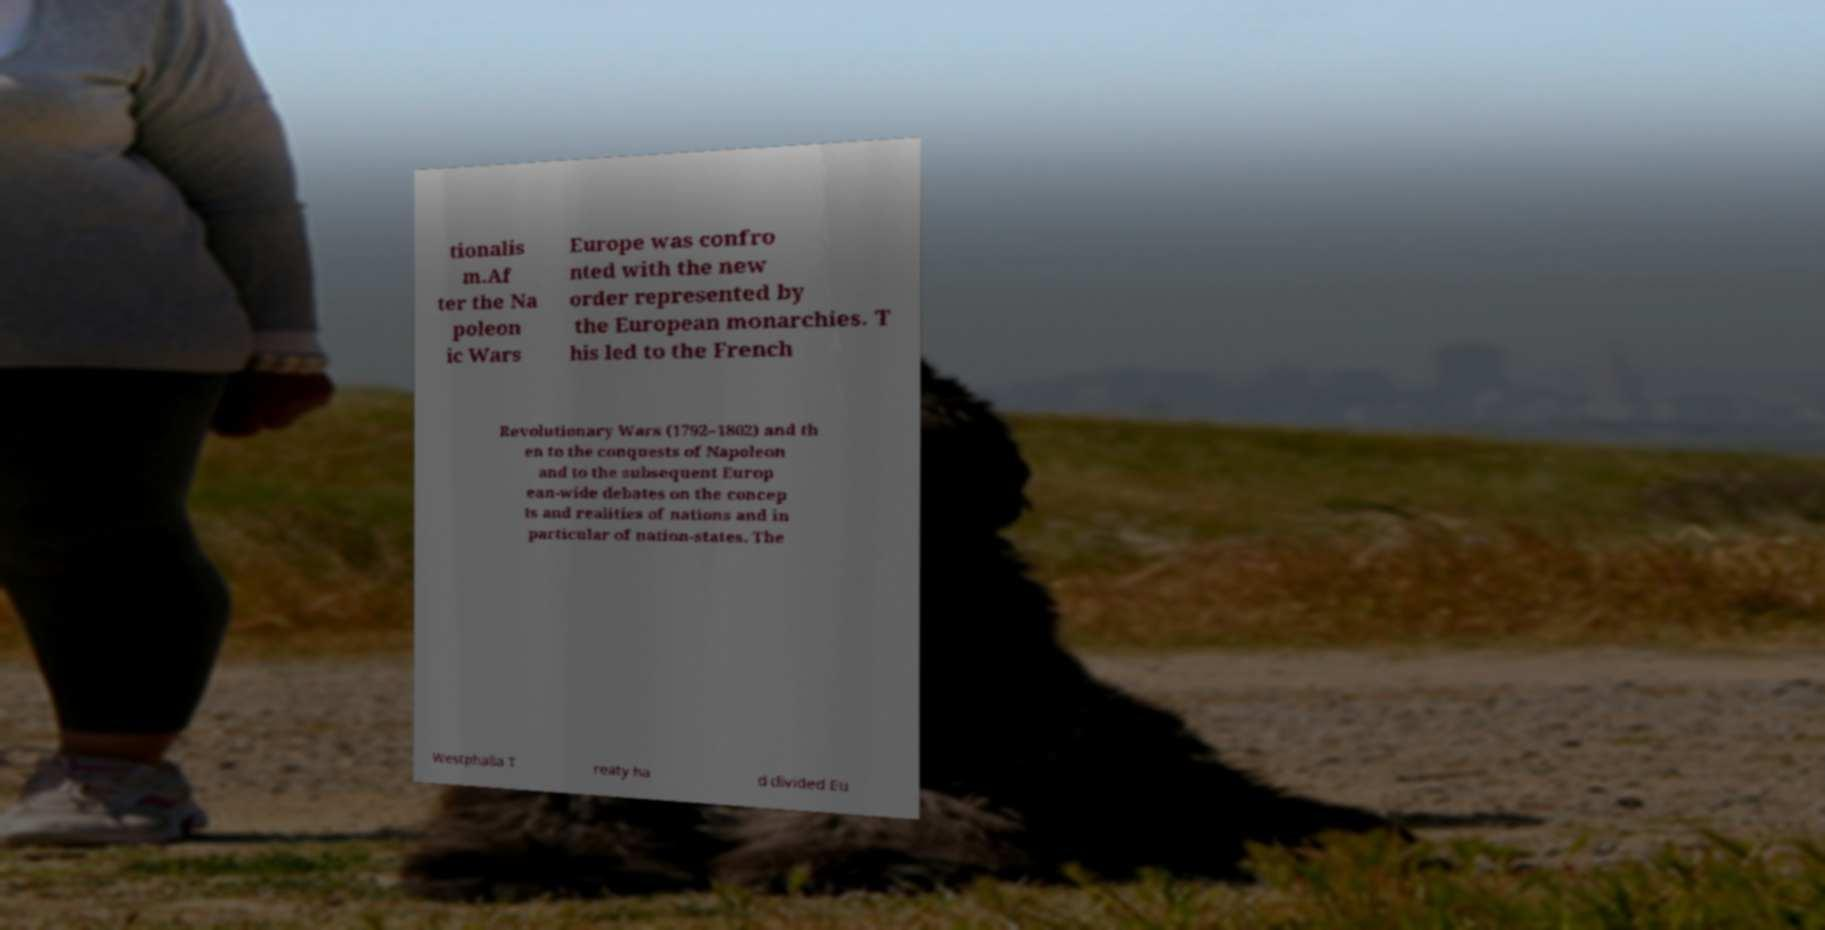Can you accurately transcribe the text from the provided image for me? tionalis m.Af ter the Na poleon ic Wars Europe was confro nted with the new order represented by the European monarchies. T his led to the French Revolutionary Wars (1792–1802) and th en to the conquests of Napoleon and to the subsequent Europ ean-wide debates on the concep ts and realities of nations and in particular of nation-states. The Westphalia T reaty ha d divided Eu 